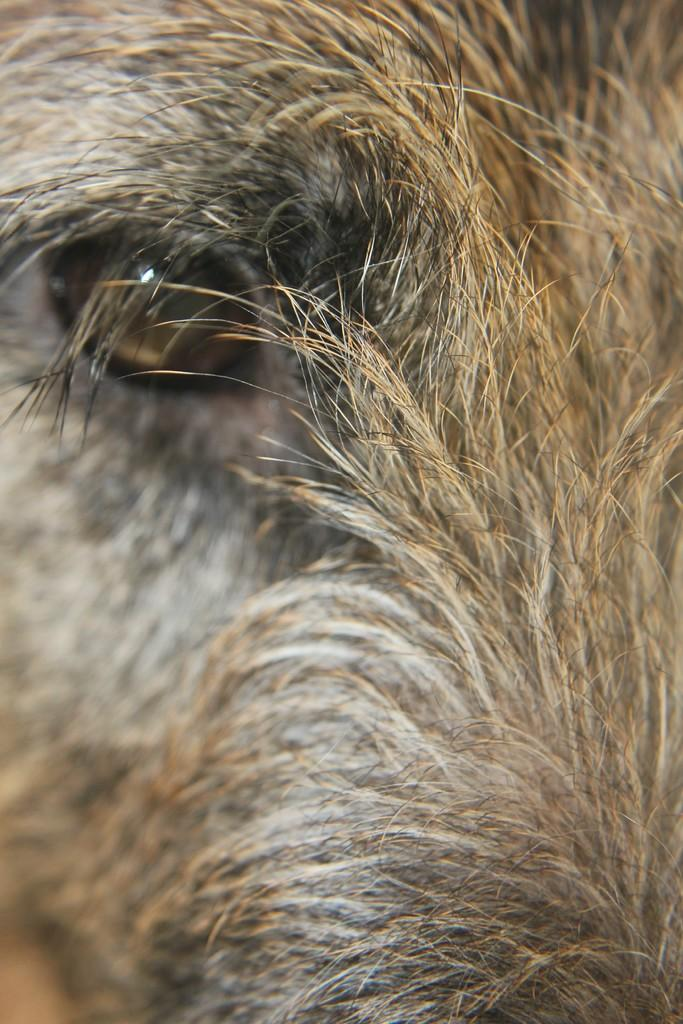What is the main subject of the image? The main subject of the image is the face of an animal. What hobbies does the rock have in the image? There is no rock present in the image, and therefore no hobbies can be attributed to it. 